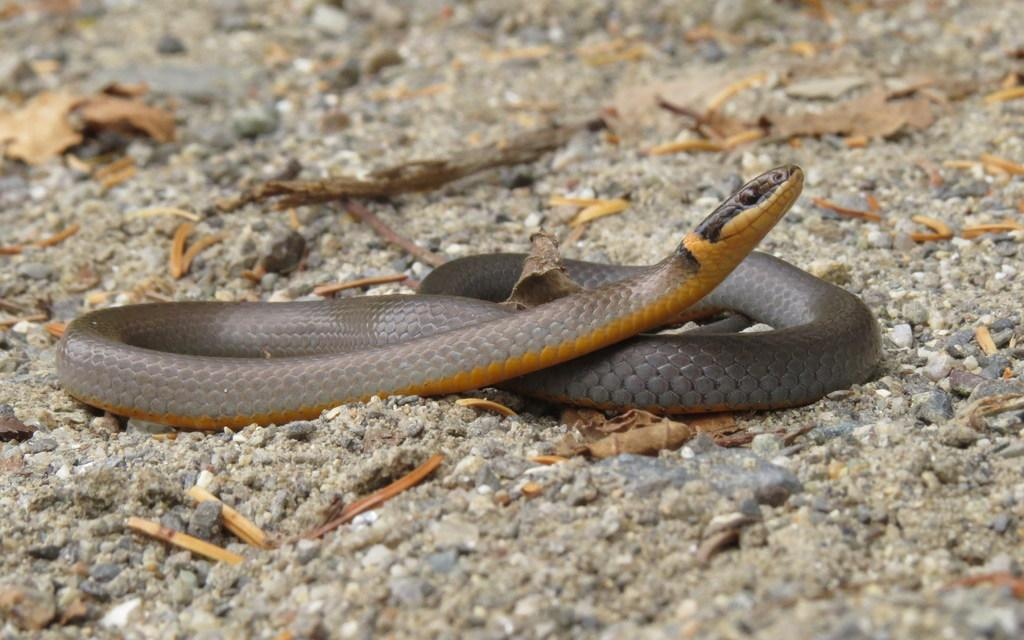What type of animal is in the image? There is a snake in the image. What material are some of the objects in the image made of? There are wooden objects in the image. Where are the snake and wooden objects located? The snake and wooden objects are on the land. What type of porter is carrying the snake across the border in the image? There is no porter or border present in the image; it only features a snake and wooden objects on the land. 